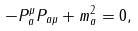<formula> <loc_0><loc_0><loc_500><loc_500>- P _ { a } ^ { \mu } P _ { a \mu } + m _ { a } ^ { 2 } = 0 ,</formula> 